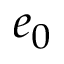Convert formula to latex. <formula><loc_0><loc_0><loc_500><loc_500>e _ { 0 }</formula> 